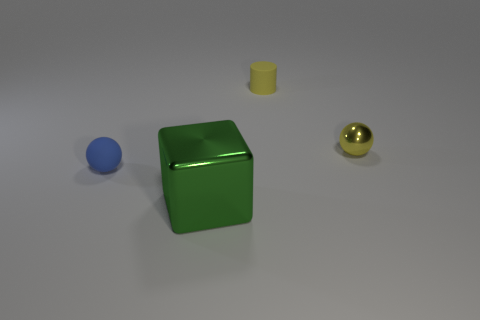Add 1 tiny cyan rubber cubes. How many objects exist? 5 Subtract all blocks. How many objects are left? 3 Add 1 small green cubes. How many small green cubes exist? 1 Subtract 0 red cubes. How many objects are left? 4 Subtract all red matte cylinders. Subtract all cubes. How many objects are left? 3 Add 2 small metal spheres. How many small metal spheres are left? 3 